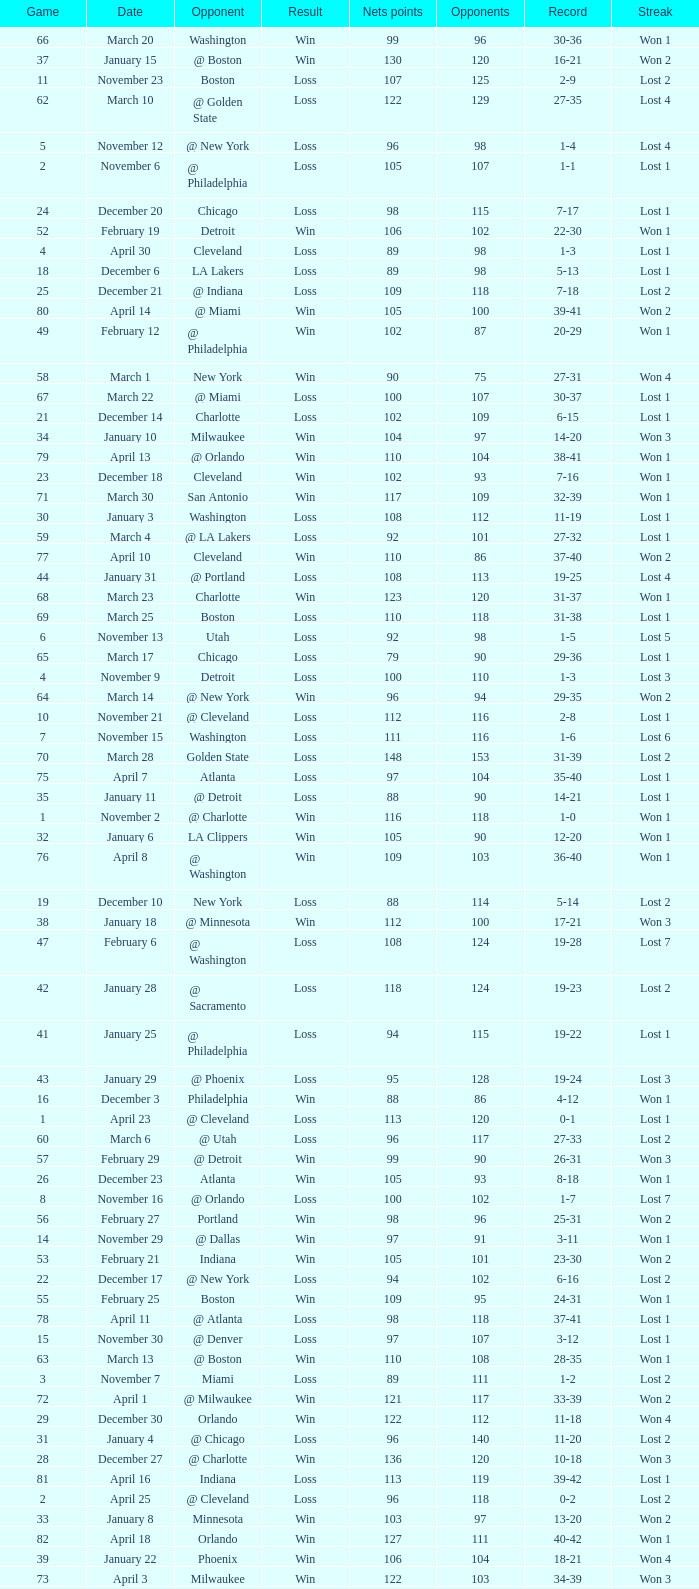How many games had fewer than 118 opponents and more than 109 net points with an opponent of Washington? 1.0. Could you help me parse every detail presented in this table? {'header': ['Game', 'Date', 'Opponent', 'Result', 'Nets points', 'Opponents', 'Record', 'Streak'], 'rows': [['66', 'March 20', 'Washington', 'Win', '99', '96', '30-36', 'Won 1'], ['37', 'January 15', '@ Boston', 'Win', '130', '120', '16-21', 'Won 2'], ['11', 'November 23', 'Boston', 'Loss', '107', '125', '2-9', 'Lost 2'], ['62', 'March 10', '@ Golden State', 'Loss', '122', '129', '27-35', 'Lost 4'], ['5', 'November 12', '@ New York', 'Loss', '96', '98', '1-4', 'Lost 4'], ['2', 'November 6', '@ Philadelphia', 'Loss', '105', '107', '1-1', 'Lost 1'], ['24', 'December 20', 'Chicago', 'Loss', '98', '115', '7-17', 'Lost 1'], ['52', 'February 19', 'Detroit', 'Win', '106', '102', '22-30', 'Won 1'], ['4', 'April 30', 'Cleveland', 'Loss', '89', '98', '1-3', 'Lost 1'], ['18', 'December 6', 'LA Lakers', 'Loss', '89', '98', '5-13', 'Lost 1'], ['25', 'December 21', '@ Indiana', 'Loss', '109', '118', '7-18', 'Lost 2'], ['80', 'April 14', '@ Miami', 'Win', '105', '100', '39-41', 'Won 2'], ['49', 'February 12', '@ Philadelphia', 'Win', '102', '87', '20-29', 'Won 1'], ['58', 'March 1', 'New York', 'Win', '90', '75', '27-31', 'Won 4'], ['67', 'March 22', '@ Miami', 'Loss', '100', '107', '30-37', 'Lost 1'], ['21', 'December 14', 'Charlotte', 'Loss', '102', '109', '6-15', 'Lost 1'], ['34', 'January 10', 'Milwaukee', 'Win', '104', '97', '14-20', 'Won 3'], ['79', 'April 13', '@ Orlando', 'Win', '110', '104', '38-41', 'Won 1'], ['23', 'December 18', 'Cleveland', 'Win', '102', '93', '7-16', 'Won 1'], ['71', 'March 30', 'San Antonio', 'Win', '117', '109', '32-39', 'Won 1'], ['30', 'January 3', 'Washington', 'Loss', '108', '112', '11-19', 'Lost 1'], ['59', 'March 4', '@ LA Lakers', 'Loss', '92', '101', '27-32', 'Lost 1'], ['77', 'April 10', 'Cleveland', 'Win', '110', '86', '37-40', 'Won 2'], ['44', 'January 31', '@ Portland', 'Loss', '108', '113', '19-25', 'Lost 4'], ['68', 'March 23', 'Charlotte', 'Win', '123', '120', '31-37', 'Won 1'], ['69', 'March 25', 'Boston', 'Loss', '110', '118', '31-38', 'Lost 1'], ['6', 'November 13', 'Utah', 'Loss', '92', '98', '1-5', 'Lost 5'], ['65', 'March 17', 'Chicago', 'Loss', '79', '90', '29-36', 'Lost 1'], ['4', 'November 9', 'Detroit', 'Loss', '100', '110', '1-3', 'Lost 3'], ['64', 'March 14', '@ New York', 'Win', '96', '94', '29-35', 'Won 2'], ['10', 'November 21', '@ Cleveland', 'Loss', '112', '116', '2-8', 'Lost 1'], ['7', 'November 15', 'Washington', 'Loss', '111', '116', '1-6', 'Lost 6'], ['70', 'March 28', 'Golden State', 'Loss', '148', '153', '31-39', 'Lost 2'], ['75', 'April 7', 'Atlanta', 'Loss', '97', '104', '35-40', 'Lost 1'], ['35', 'January 11', '@ Detroit', 'Loss', '88', '90', '14-21', 'Lost 1'], ['1', 'November 2', '@ Charlotte', 'Win', '116', '118', '1-0', 'Won 1'], ['32', 'January 6', 'LA Clippers', 'Win', '105', '90', '12-20', 'Won 1'], ['76', 'April 8', '@ Washington', 'Win', '109', '103', '36-40', 'Won 1'], ['19', 'December 10', 'New York', 'Loss', '88', '114', '5-14', 'Lost 2'], ['38', 'January 18', '@ Minnesota', 'Win', '112', '100', '17-21', 'Won 3'], ['47', 'February 6', '@ Washington', 'Loss', '108', '124', '19-28', 'Lost 7'], ['42', 'January 28', '@ Sacramento', 'Loss', '118', '124', '19-23', 'Lost 2'], ['41', 'January 25', '@ Philadelphia', 'Loss', '94', '115', '19-22', 'Lost 1'], ['43', 'January 29', '@ Phoenix', 'Loss', '95', '128', '19-24', 'Lost 3'], ['16', 'December 3', 'Philadelphia', 'Win', '88', '86', '4-12', 'Won 1'], ['1', 'April 23', '@ Cleveland', 'Loss', '113', '120', '0-1', 'Lost 1'], ['60', 'March 6', '@ Utah', 'Loss', '96', '117', '27-33', 'Lost 2'], ['57', 'February 29', '@ Detroit', 'Win', '99', '90', '26-31', 'Won 3'], ['26', 'December 23', 'Atlanta', 'Win', '105', '93', '8-18', 'Won 1'], ['8', 'November 16', '@ Orlando', 'Loss', '100', '102', '1-7', 'Lost 7'], ['56', 'February 27', 'Portland', 'Win', '98', '96', '25-31', 'Won 2'], ['14', 'November 29', '@ Dallas', 'Win', '97', '91', '3-11', 'Won 1'], ['53', 'February 21', 'Indiana', 'Win', '105', '101', '23-30', 'Won 2'], ['22', 'December 17', '@ New York', 'Loss', '94', '102', '6-16', 'Lost 2'], ['55', 'February 25', 'Boston', 'Win', '109', '95', '24-31', 'Won 1'], ['78', 'April 11', '@ Atlanta', 'Loss', '98', '118', '37-41', 'Lost 1'], ['15', 'November 30', '@ Denver', 'Loss', '97', '107', '3-12', 'Lost 1'], ['63', 'March 13', '@ Boston', 'Win', '110', '108', '28-35', 'Won 1'], ['3', 'November 7', 'Miami', 'Loss', '89', '111', '1-2', 'Lost 2'], ['72', 'April 1', '@ Milwaukee', 'Win', '121', '117', '33-39', 'Won 2'], ['29', 'December 30', 'Orlando', 'Win', '122', '112', '11-18', 'Won 4'], ['31', 'January 4', '@ Chicago', 'Loss', '96', '140', '11-20', 'Lost 2'], ['28', 'December 27', '@ Charlotte', 'Win', '136', '120', '10-18', 'Won 3'], ['81', 'April 16', 'Indiana', 'Loss', '113', '119', '39-42', 'Lost 1'], ['2', 'April 25', '@ Cleveland', 'Loss', '96', '118', '0-2', 'Lost 2'], ['33', 'January 8', 'Minnesota', 'Win', '103', '97', '13-20', 'Won 2'], ['82', 'April 18', 'Orlando', 'Win', '127', '111', '40-42', 'Won 1'], ['39', 'January 22', 'Phoenix', 'Win', '106', '104', '18-21', 'Won 4'], ['73', 'April 3', 'Milwaukee', 'Win', '122', '103', '34-39', 'Won 3'], ['17', 'December 5', '@ Milwaukee', 'Win', '109', '101', '5-12', 'Won 2'], ['27', 'December 26', 'Houston', 'Win', '99', '93', '9-18', 'Won 2'], ['74', 'April 5', '@ Indiana', 'Win', '128', '120', '35-39', 'Won 4'], ['61', 'March 7', '@ Seattle', 'Loss', '98', '109', '27-34', 'Lost 3'], ['20', 'December 12', 'Denver', 'Win', '121', '81', '6-14', 'Won 1'], ['48', 'February 11', '@ Chicago', 'Loss', '113', '133', '19-29', 'Lost 8'], ['12', 'November 26', '@ Houston', 'Loss', '109', '118', '2-10', 'Lost 3'], ['45', 'February 1', '@ LA Clippers', 'Loss', '88', '99', '19-26', 'Lost 5'], ['36', 'January 14', 'Dallas', 'Win', '97', '88', '15-21', 'Won 1'], ['3', 'April 28', 'Cleveland', 'Win', '109', '104', '1-2', 'Won 1'], ['50', 'February 14', 'Philadelphia', 'Win', '107', '99', '21-29', 'Won 2'], ['54', 'February 22', '@ Atlanta', 'Loss', '107', '119', '23-31', 'Lost 1'], ['13', 'November 27', '@ San Antonio', 'Loss', '100', '106', '2-11', 'Lost 4'], ['46', 'February 5', 'Seattle', 'Loss', '85', '95', '19-27', 'Lost 6'], ['9', 'November 19', 'Sacramento', 'Win', '122', '118', '2-7', 'Won 1'], ['51', 'February 15', '@ Cleveland', 'Loss', '92', '128', '21-30', 'Lost 1'], ['40', 'January 24', 'Miami', 'Win', '123', '117', '19-21', 'Won 5']]} 